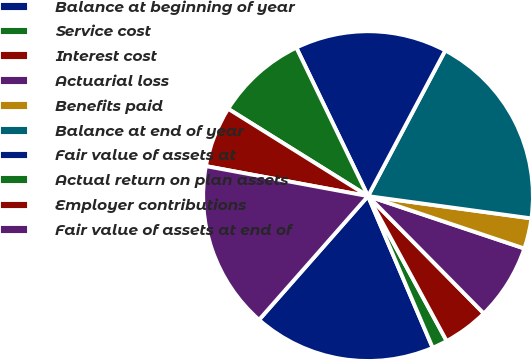Convert chart to OTSL. <chart><loc_0><loc_0><loc_500><loc_500><pie_chart><fcel>Balance at beginning of year<fcel>Service cost<fcel>Interest cost<fcel>Actuarial loss<fcel>Benefits paid<fcel>Balance at end of year<fcel>Fair value of assets at<fcel>Actual return on plan assets<fcel>Employer contributions<fcel>Fair value of assets at end of<nl><fcel>17.91%<fcel>1.5%<fcel>4.48%<fcel>7.46%<fcel>2.99%<fcel>19.4%<fcel>14.92%<fcel>8.96%<fcel>5.97%<fcel>16.42%<nl></chart> 